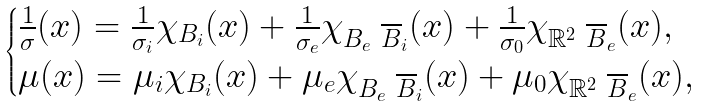Convert formula to latex. <formula><loc_0><loc_0><loc_500><loc_500>\begin{cases} \frac { 1 } { \sigma } ( x ) = \frac { 1 } { \sigma _ { i } } \chi _ { B _ { i } } ( x ) + \frac { 1 } { \sigma _ { e } } \chi _ { B _ { e } \ \overline { B } _ { i } } ( x ) + \frac { 1 } { \sigma _ { 0 } } \chi _ { \mathbb { R } ^ { 2 } \ \overline { B } _ { e } } ( x ) , \\ \mu ( x ) = \mu _ { i } \chi _ { B _ { i } } ( x ) + \mu _ { e } \chi _ { B _ { e } \ \overline { B } _ { i } } ( x ) + \mu _ { 0 } \chi _ { \mathbb { R } ^ { 2 } \ \overline { B } _ { e } } ( x ) , \end{cases}</formula> 